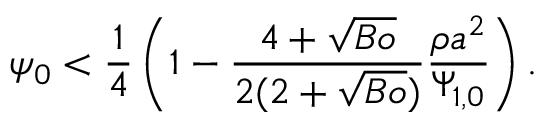Convert formula to latex. <formula><loc_0><loc_0><loc_500><loc_500>\psi _ { 0 } < \frac { 1 } { 4 } \left ( 1 - \frac { 4 + \sqrt { B o } } { 2 ( 2 + \sqrt { B o } ) } \frac { \rho { a } ^ { 2 } } { \Psi _ { 1 , 0 } } \right ) .</formula> 